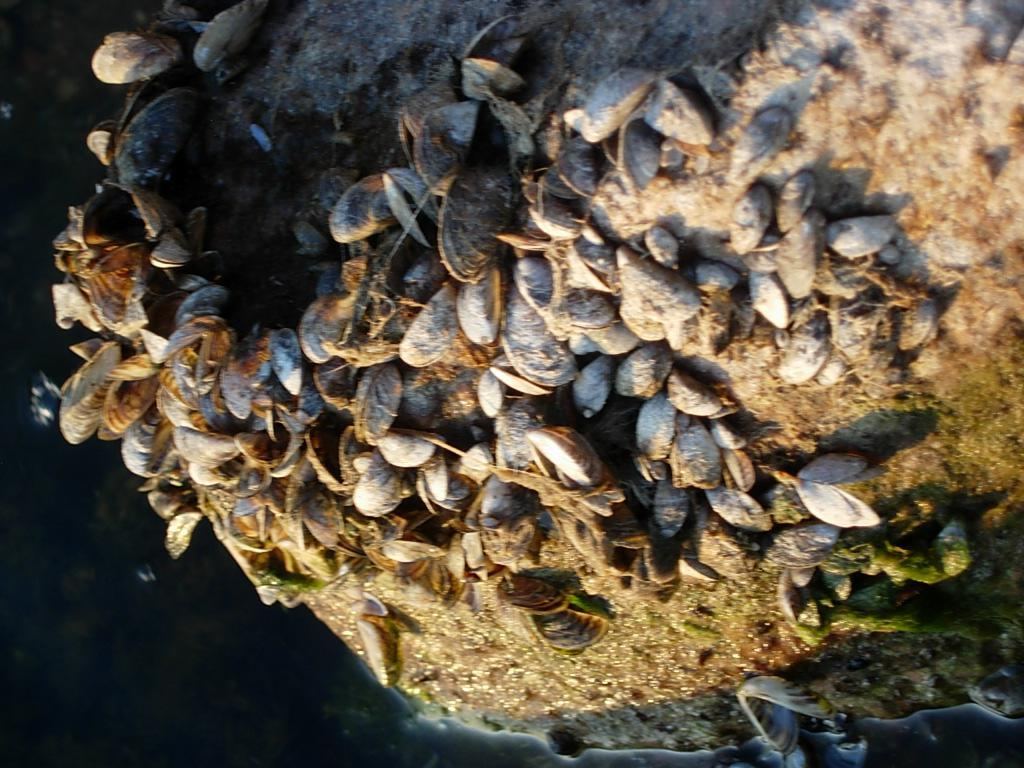What objects can be seen on the ground in the image? There are shells on the ground in the image. What can be seen on the left side of the image? There is water visible on the left side of the image. What type of straw is being used to plough the water in the image? There is no plough or straw present in the image; it features shells on the ground and water on the left side. 